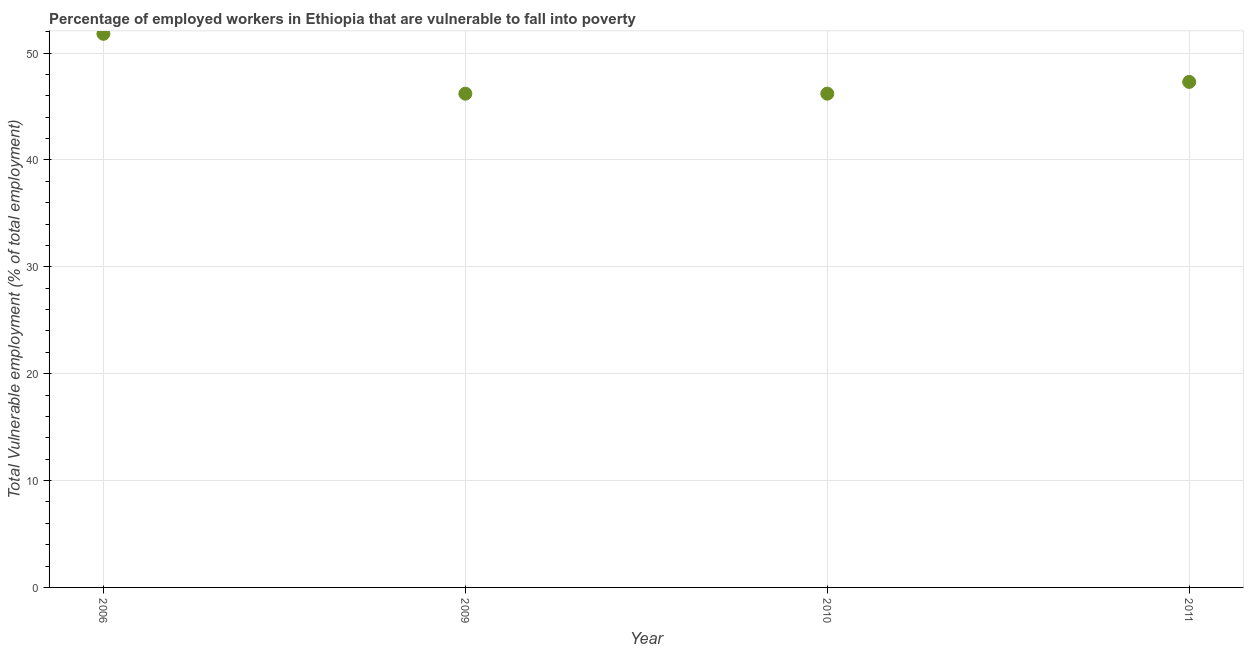What is the total vulnerable employment in 2009?
Your answer should be very brief. 46.2. Across all years, what is the maximum total vulnerable employment?
Offer a terse response. 51.8. Across all years, what is the minimum total vulnerable employment?
Provide a succinct answer. 46.2. In which year was the total vulnerable employment maximum?
Provide a short and direct response. 2006. What is the sum of the total vulnerable employment?
Your response must be concise. 191.5. What is the difference between the total vulnerable employment in 2009 and 2010?
Offer a very short reply. 0. What is the average total vulnerable employment per year?
Offer a terse response. 47.88. What is the median total vulnerable employment?
Make the answer very short. 46.75. In how many years, is the total vulnerable employment greater than 20 %?
Your answer should be very brief. 4. What is the ratio of the total vulnerable employment in 2009 to that in 2011?
Give a very brief answer. 0.98. What is the difference between the highest and the second highest total vulnerable employment?
Keep it short and to the point. 4.5. Is the sum of the total vulnerable employment in 2006 and 2010 greater than the maximum total vulnerable employment across all years?
Make the answer very short. Yes. What is the difference between the highest and the lowest total vulnerable employment?
Provide a short and direct response. 5.6. How many dotlines are there?
Your response must be concise. 1. Are the values on the major ticks of Y-axis written in scientific E-notation?
Keep it short and to the point. No. What is the title of the graph?
Provide a short and direct response. Percentage of employed workers in Ethiopia that are vulnerable to fall into poverty. What is the label or title of the Y-axis?
Your answer should be very brief. Total Vulnerable employment (% of total employment). What is the Total Vulnerable employment (% of total employment) in 2006?
Offer a terse response. 51.8. What is the Total Vulnerable employment (% of total employment) in 2009?
Offer a terse response. 46.2. What is the Total Vulnerable employment (% of total employment) in 2010?
Offer a very short reply. 46.2. What is the Total Vulnerable employment (% of total employment) in 2011?
Keep it short and to the point. 47.3. What is the difference between the Total Vulnerable employment (% of total employment) in 2009 and 2010?
Keep it short and to the point. 0. What is the difference between the Total Vulnerable employment (% of total employment) in 2009 and 2011?
Your response must be concise. -1.1. What is the difference between the Total Vulnerable employment (% of total employment) in 2010 and 2011?
Keep it short and to the point. -1.1. What is the ratio of the Total Vulnerable employment (% of total employment) in 2006 to that in 2009?
Provide a succinct answer. 1.12. What is the ratio of the Total Vulnerable employment (% of total employment) in 2006 to that in 2010?
Give a very brief answer. 1.12. What is the ratio of the Total Vulnerable employment (% of total employment) in 2006 to that in 2011?
Keep it short and to the point. 1.09. What is the ratio of the Total Vulnerable employment (% of total employment) in 2009 to that in 2011?
Your answer should be compact. 0.98. 